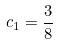<formula> <loc_0><loc_0><loc_500><loc_500>c _ { 1 } = \frac { 3 } { 8 }</formula> 